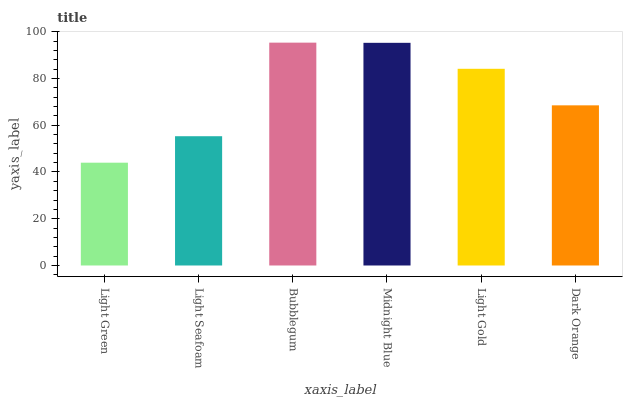Is Light Seafoam the minimum?
Answer yes or no. No. Is Light Seafoam the maximum?
Answer yes or no. No. Is Light Seafoam greater than Light Green?
Answer yes or no. Yes. Is Light Green less than Light Seafoam?
Answer yes or no. Yes. Is Light Green greater than Light Seafoam?
Answer yes or no. No. Is Light Seafoam less than Light Green?
Answer yes or no. No. Is Light Gold the high median?
Answer yes or no. Yes. Is Dark Orange the low median?
Answer yes or no. Yes. Is Bubblegum the high median?
Answer yes or no. No. Is Bubblegum the low median?
Answer yes or no. No. 